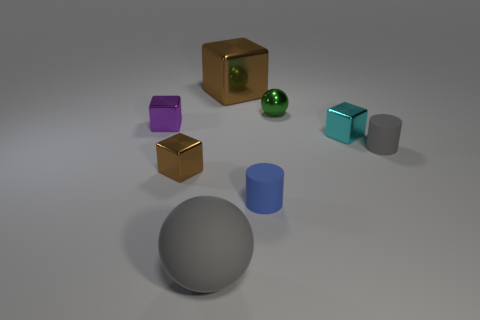Subtract all tiny shiny blocks. How many blocks are left? 1 Add 1 blue rubber cylinders. How many objects exist? 9 Subtract all purple blocks. How many blocks are left? 3 Subtract all cylinders. How many objects are left? 6 Subtract all purple cubes. Subtract all blue spheres. How many cubes are left? 3 Add 6 cyan metal cubes. How many cyan metal cubes exist? 7 Subtract 0 cyan cylinders. How many objects are left? 8 Subtract all gray balls. Subtract all matte objects. How many objects are left? 4 Add 2 tiny green metal spheres. How many tiny green metal spheres are left? 3 